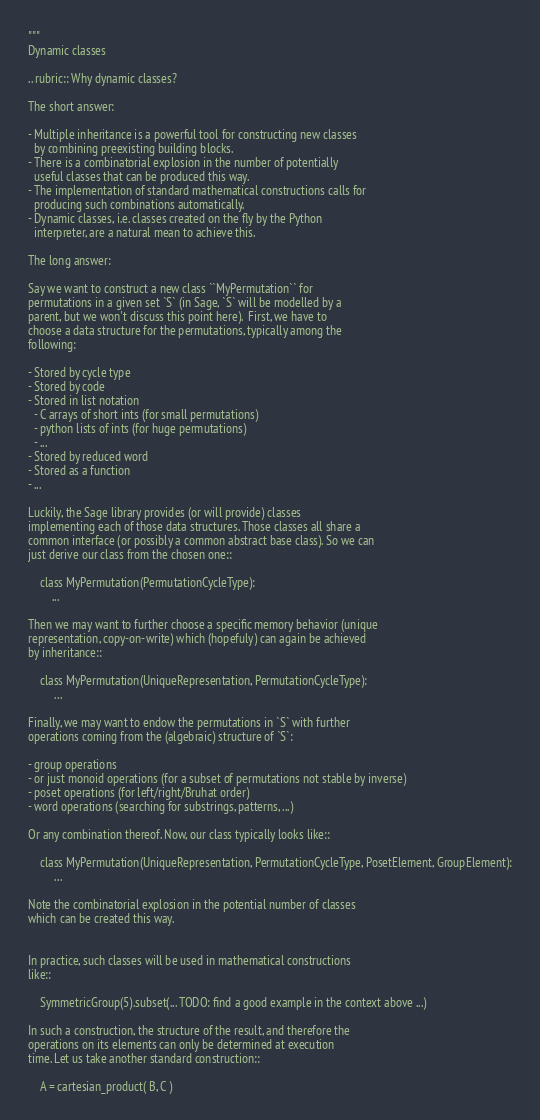<code> <loc_0><loc_0><loc_500><loc_500><_Python_>"""
Dynamic classes

.. rubric:: Why dynamic classes?

The short answer:

- Multiple inheritance is a powerful tool for constructing new classes
  by combining preexisting building blocks.
- There is a combinatorial explosion in the number of potentially
  useful classes that can be produced this way.
- The implementation of standard mathematical constructions calls for
  producing such combinations automatically.
- Dynamic classes, i.e. classes created on the fly by the Python
  interpreter, are a natural mean to achieve this.

The long answer:

Say we want to construct a new class ``MyPermutation`` for
permutations in a given set `S` (in Sage, `S` will be modelled by a
parent, but we won't discuss this point here).  First, we have to
choose a data structure for the permutations, typically among the
following:

- Stored by cycle type
- Stored by code
- Stored in list notation
  - C arrays of short ints (for small permutations)
  - python lists of ints (for huge permutations)
  - ...
- Stored by reduced word
- Stored as a function
- ...

Luckily, the Sage library provides (or will provide) classes
implementing each of those data structures. Those classes all share a
common interface (or possibly a common abstract base class). So we can
just derive our class from the chosen one::

    class MyPermutation(PermutationCycleType):
        ...

Then we may want to further choose a specific memory behavior (unique
representation, copy-on-write) which (hopefuly) can again be achieved
by inheritance::

    class MyPermutation(UniqueRepresentation, PermutationCycleType):
         ...

Finally, we may want to endow the permutations in `S` with further
operations coming from the (algebraic) structure of `S`:

- group operations
- or just monoid operations (for a subset of permutations not stable by inverse)
- poset operations (for left/right/Bruhat order)
- word operations (searching for substrings, patterns, ...)

Or any combination thereof. Now, our class typically looks like::

    class MyPermutation(UniqueRepresentation, PermutationCycleType, PosetElement, GroupElement):
         ...

Note the combinatorial explosion in the potential number of classes
which can be created this way.


In practice, such classes will be used in mathematical constructions
like::

    SymmetricGroup(5).subset(... TODO: find a good example in the context above ...)

In such a construction, the structure of the result, and therefore the
operations on its elements can only be determined at execution
time. Let us take another standard construction::

    A = cartesian_product( B, C )
</code> 